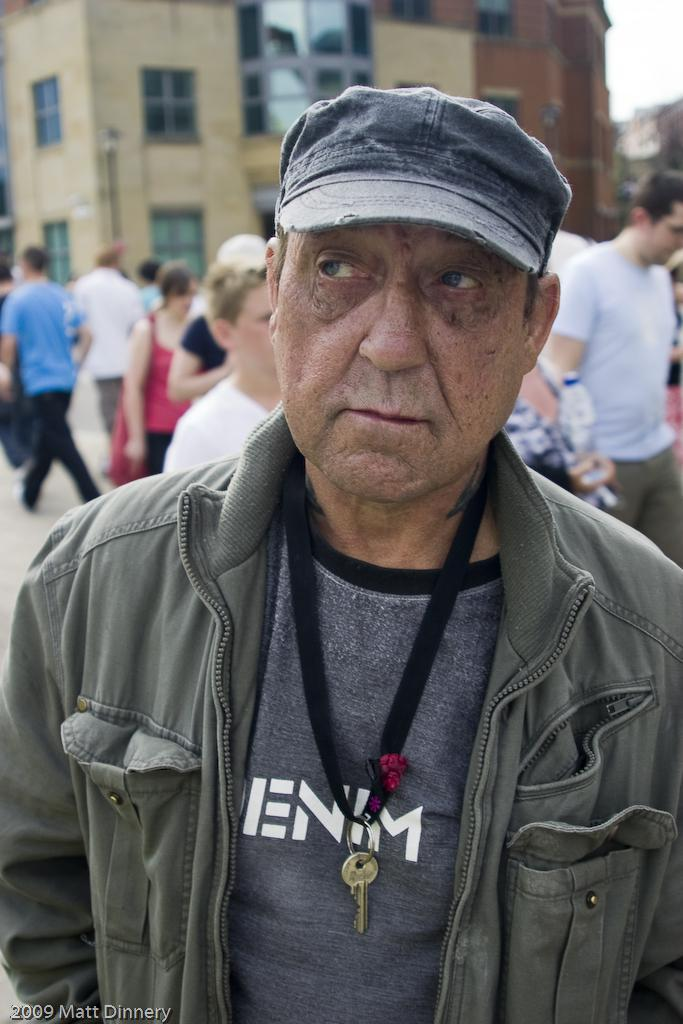What can be seen in the image? There is a group of people in the image. Can you describe the man in the middle of the image? The man in the middle of the image is wearing a cap. What is visible in the background of the image? There are buildings in the background of the image. What type of cracker is the man holding in the image? There is no cracker present in the image. What direction is the cook facing in the image? There is no cook present in the image. 